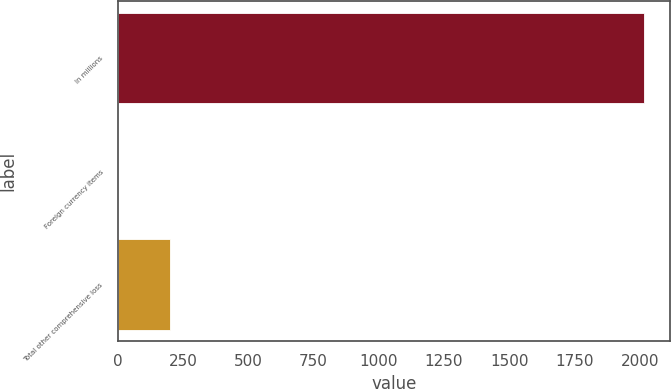<chart> <loc_0><loc_0><loc_500><loc_500><bar_chart><fcel>In millions<fcel>Foreign currency items<fcel>Total other comprehensive loss<nl><fcel>2016<fcel>0.4<fcel>201.96<nl></chart> 